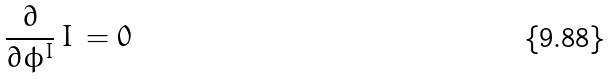Convert formula to latex. <formula><loc_0><loc_0><loc_500><loc_500>\frac { \partial } { \partial \phi ^ { I } } \, I \, = 0</formula> 